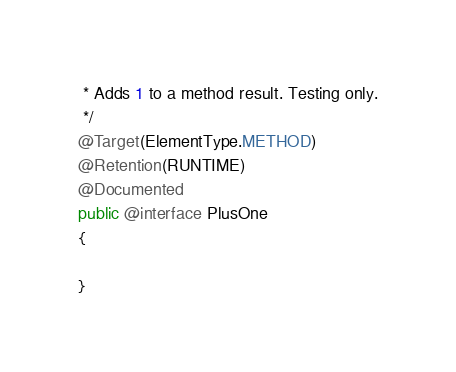Convert code to text. <code><loc_0><loc_0><loc_500><loc_500><_Java_> * Adds 1 to a method result. Testing only.
 */
@Target(ElementType.METHOD)
@Retention(RUNTIME)
@Documented
public @interface PlusOne
{

}
</code> 